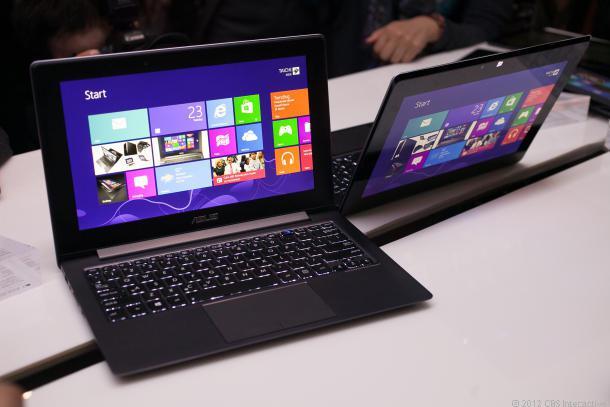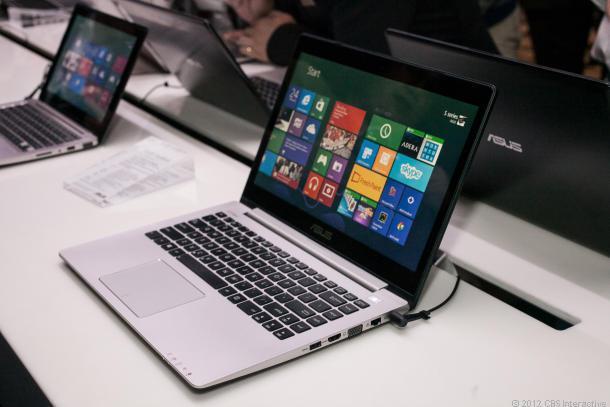The first image is the image on the left, the second image is the image on the right. For the images shown, is this caption "There are two computers in total." true? Answer yes or no. No. The first image is the image on the left, the second image is the image on the right. Analyze the images presented: Is the assertion "A finger is pointing to an open laptop screen displaying a grid of rectangles and squares in the left image." valid? Answer yes or no. No. 